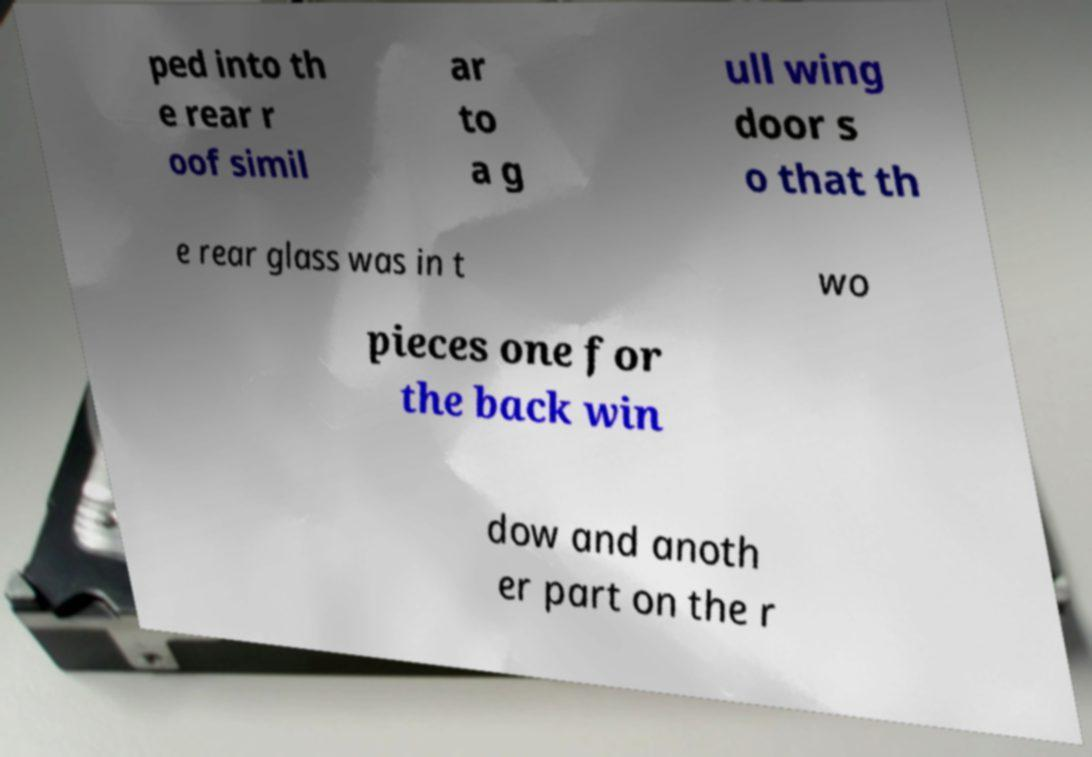I need the written content from this picture converted into text. Can you do that? ped into th e rear r oof simil ar to a g ull wing door s o that th e rear glass was in t wo pieces one for the back win dow and anoth er part on the r 